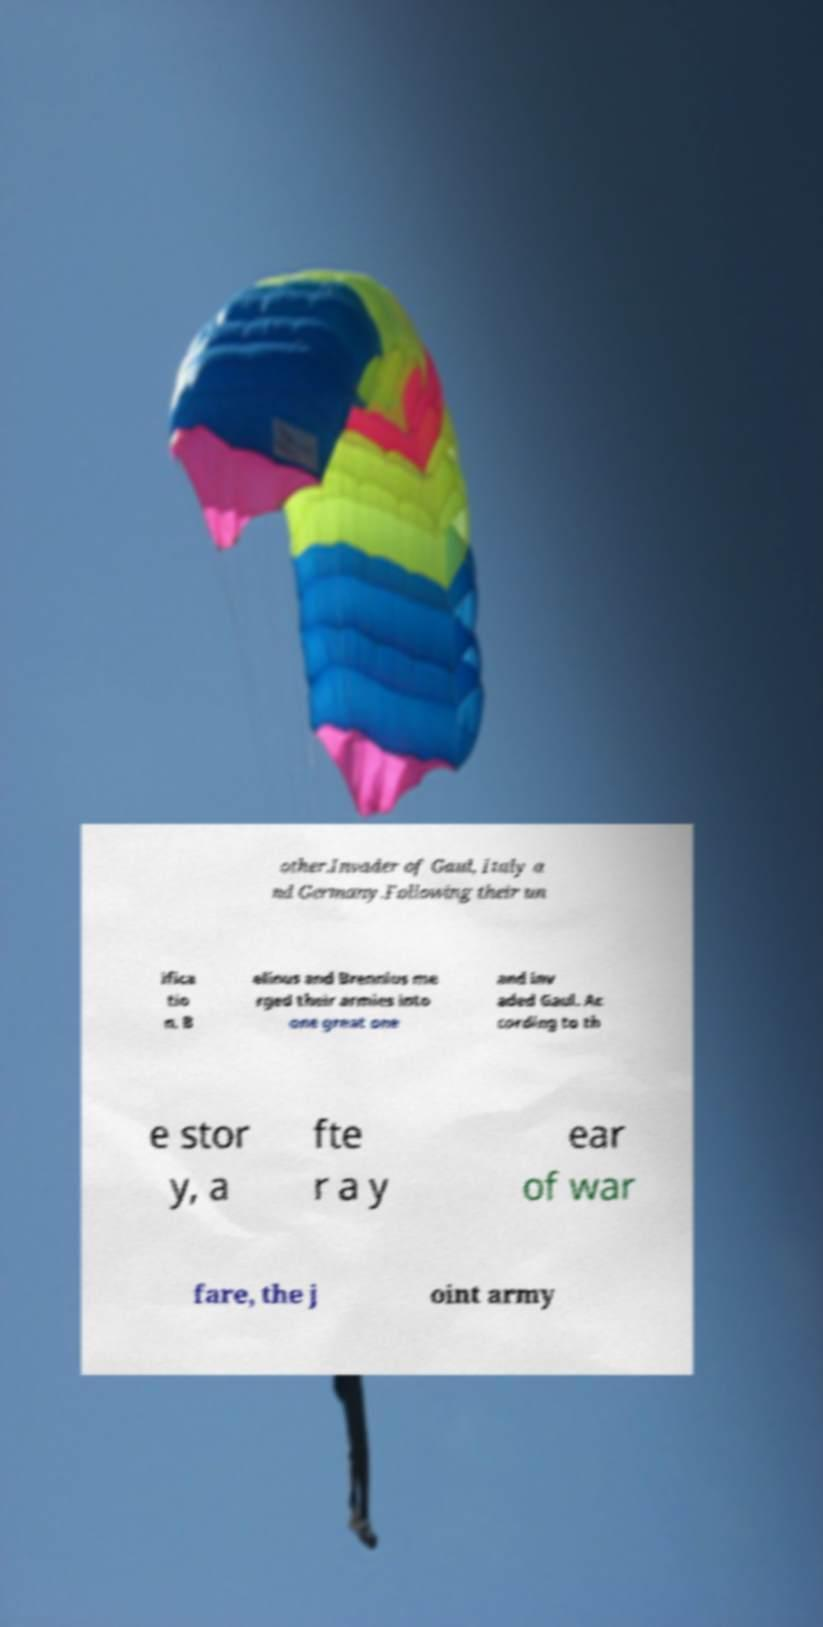Can you read and provide the text displayed in the image?This photo seems to have some interesting text. Can you extract and type it out for me? other.Invader of Gaul, Italy a nd Germany.Following their un ifica tio n, B elinus and Brennius me rged their armies into one great one and inv aded Gaul. Ac cording to th e stor y, a fte r a y ear of war fare, the j oint army 